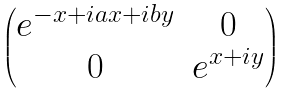Convert formula to latex. <formula><loc_0><loc_0><loc_500><loc_500>\begin{pmatrix} e ^ { - x + i a x + i b y } & 0 \\ 0 & e ^ { x + i y } \end{pmatrix}</formula> 